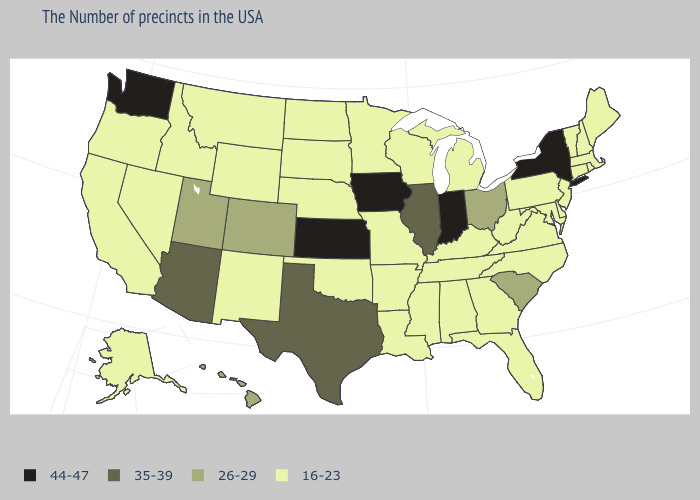What is the lowest value in states that border Rhode Island?
Answer briefly. 16-23. Name the states that have a value in the range 26-29?
Quick response, please. South Carolina, Ohio, Colorado, Utah, Hawaii. What is the value of South Carolina?
Be succinct. 26-29. What is the highest value in the USA?
Be succinct. 44-47. Among the states that border North Carolina , which have the lowest value?
Short answer required. Virginia, Georgia, Tennessee. Which states have the lowest value in the USA?
Keep it brief. Maine, Massachusetts, Rhode Island, New Hampshire, Vermont, Connecticut, New Jersey, Delaware, Maryland, Pennsylvania, Virginia, North Carolina, West Virginia, Florida, Georgia, Michigan, Kentucky, Alabama, Tennessee, Wisconsin, Mississippi, Louisiana, Missouri, Arkansas, Minnesota, Nebraska, Oklahoma, South Dakota, North Dakota, Wyoming, New Mexico, Montana, Idaho, Nevada, California, Oregon, Alaska. Does Illinois have the highest value in the USA?
Concise answer only. No. What is the value of Louisiana?
Be succinct. 16-23. Name the states that have a value in the range 26-29?
Write a very short answer. South Carolina, Ohio, Colorado, Utah, Hawaii. What is the lowest value in states that border Michigan?
Write a very short answer. 16-23. What is the value of Missouri?
Give a very brief answer. 16-23. What is the lowest value in states that border Florida?
Give a very brief answer. 16-23. Does the map have missing data?
Answer briefly. No. What is the value of North Carolina?
Give a very brief answer. 16-23. Among the states that border Nebraska , does Iowa have the lowest value?
Be succinct. No. 